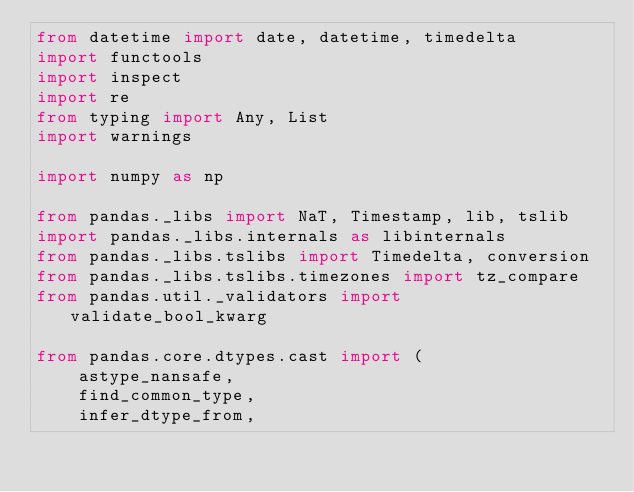Convert code to text. <code><loc_0><loc_0><loc_500><loc_500><_Python_>from datetime import date, datetime, timedelta
import functools
import inspect
import re
from typing import Any, List
import warnings

import numpy as np

from pandas._libs import NaT, Timestamp, lib, tslib
import pandas._libs.internals as libinternals
from pandas._libs.tslibs import Timedelta, conversion
from pandas._libs.tslibs.timezones import tz_compare
from pandas.util._validators import validate_bool_kwarg

from pandas.core.dtypes.cast import (
    astype_nansafe,
    find_common_type,
    infer_dtype_from,</code> 